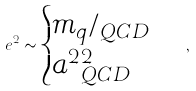Convert formula to latex. <formula><loc_0><loc_0><loc_500><loc_500>\ e ^ { 2 } \sim \begin{cases} m _ { q } / \L _ { Q C D } \\ a ^ { 2 } \L _ { Q C D } ^ { 2 } \end{cases} \, ,</formula> 